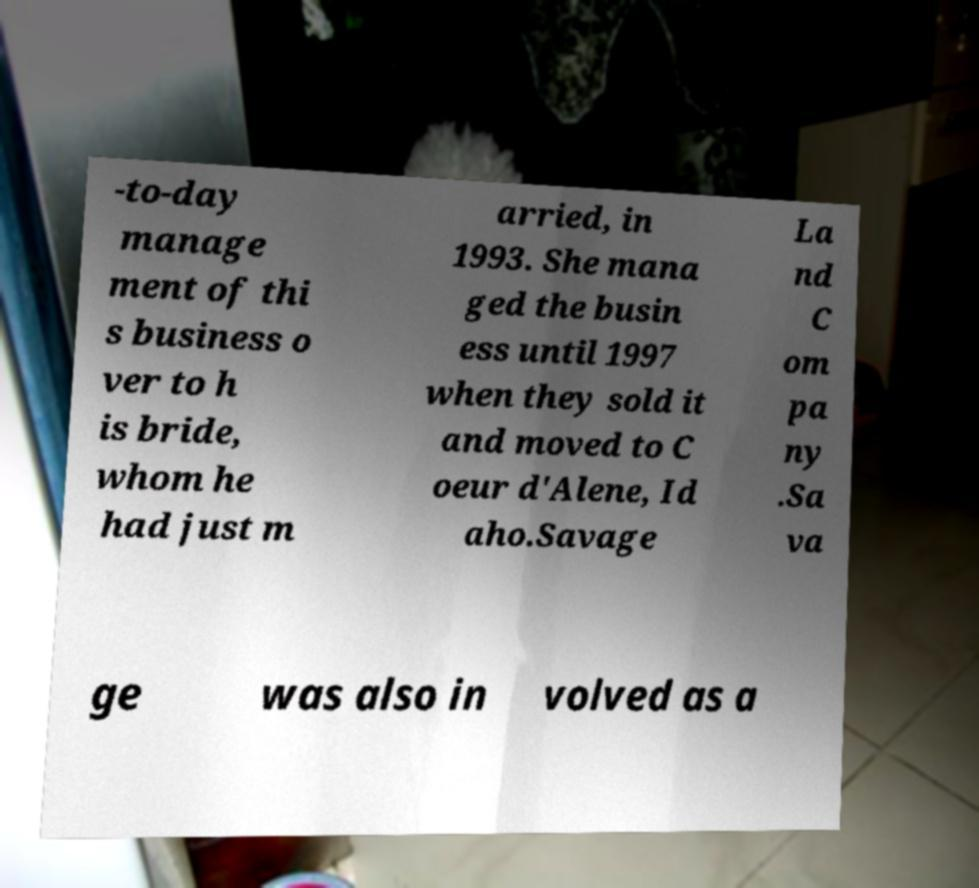Can you read and provide the text displayed in the image?This photo seems to have some interesting text. Can you extract and type it out for me? -to-day manage ment of thi s business o ver to h is bride, whom he had just m arried, in 1993. She mana ged the busin ess until 1997 when they sold it and moved to C oeur d'Alene, Id aho.Savage La nd C om pa ny .Sa va ge was also in volved as a 